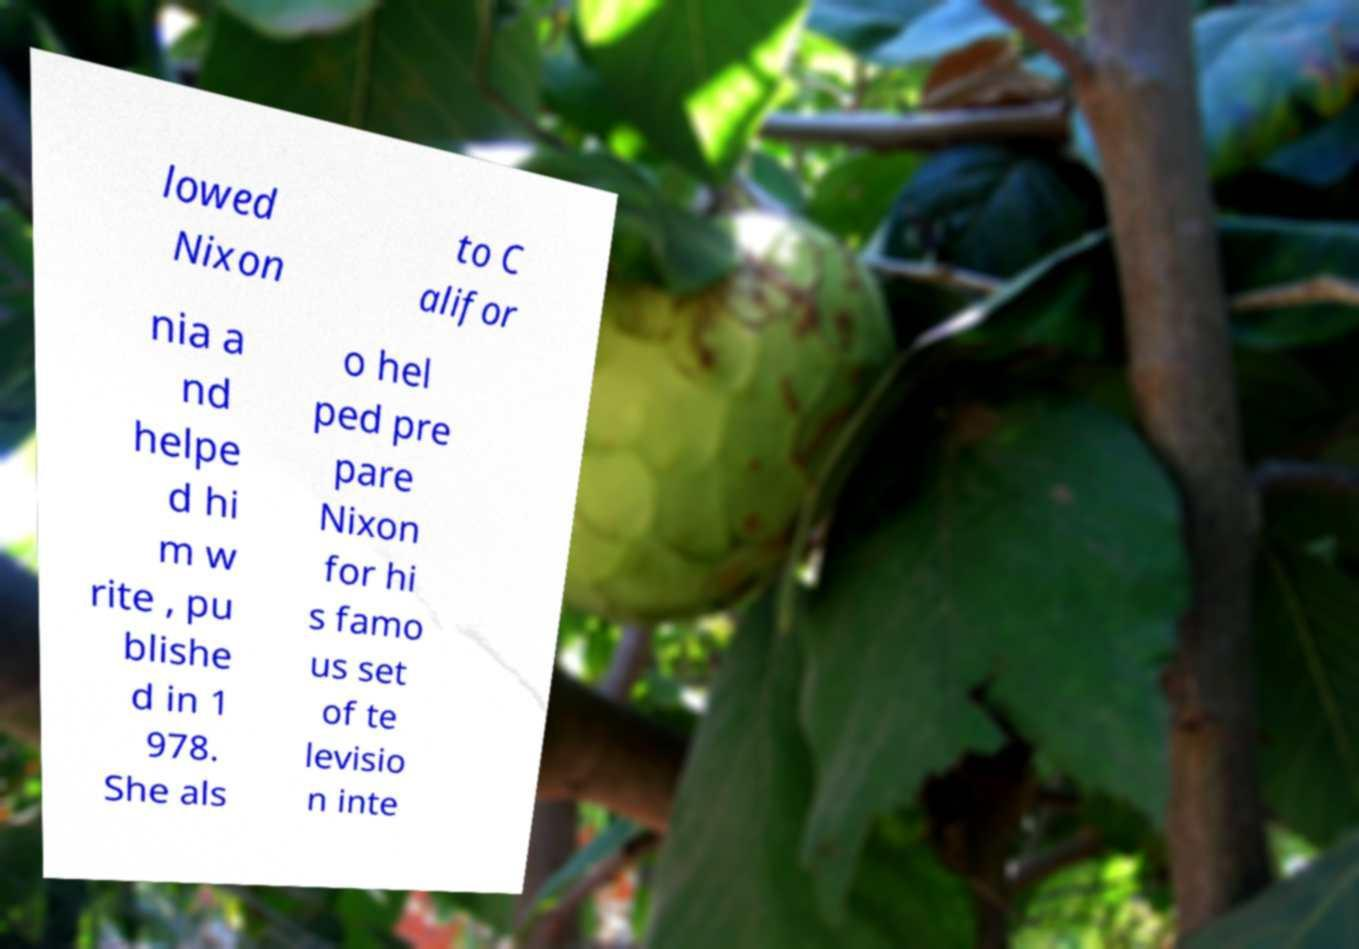There's text embedded in this image that I need extracted. Can you transcribe it verbatim? lowed Nixon to C alifor nia a nd helpe d hi m w rite , pu blishe d in 1 978. She als o hel ped pre pare Nixon for hi s famo us set of te levisio n inte 